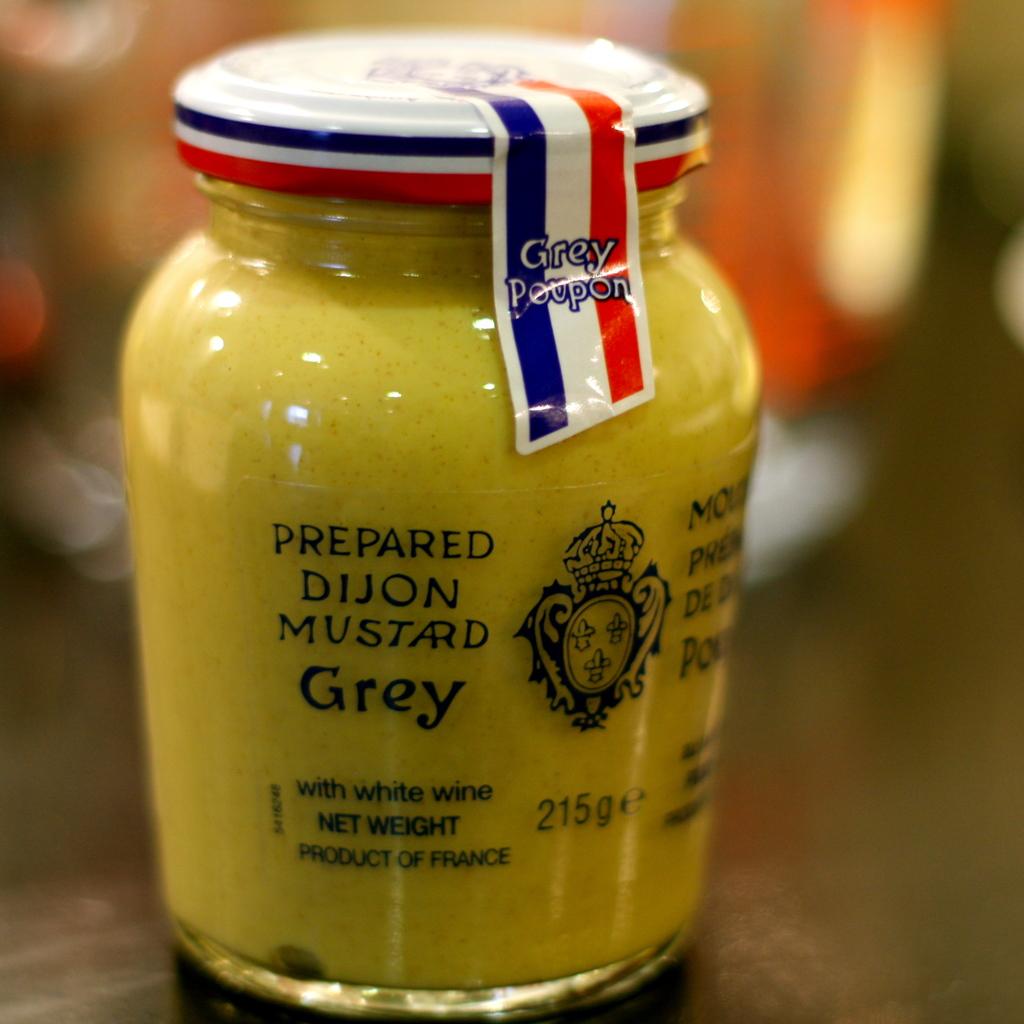What is the net weight of the product?
Provide a succinct answer. 215g. What country is this a product of?
Make the answer very short. France. 